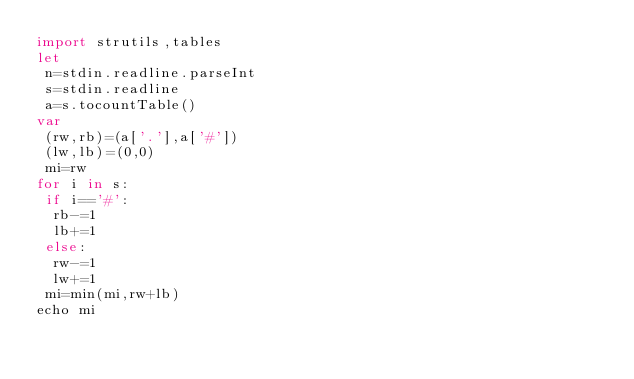Convert code to text. <code><loc_0><loc_0><loc_500><loc_500><_Nim_>import strutils,tables
let
 n=stdin.readline.parseInt
 s=stdin.readline
 a=s.tocountTable()
var
 (rw,rb)=(a['.'],a['#'])
 (lw,lb)=(0,0)
 mi=rw
for i in s:
 if i=='#':
  rb-=1
  lb+=1
 else:
  rw-=1
  lw+=1
 mi=min(mi,rw+lb)
echo mi</code> 